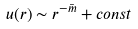Convert formula to latex. <formula><loc_0><loc_0><loc_500><loc_500>u ( r ) \sim r ^ { - \bar { m } } + c o n s t</formula> 